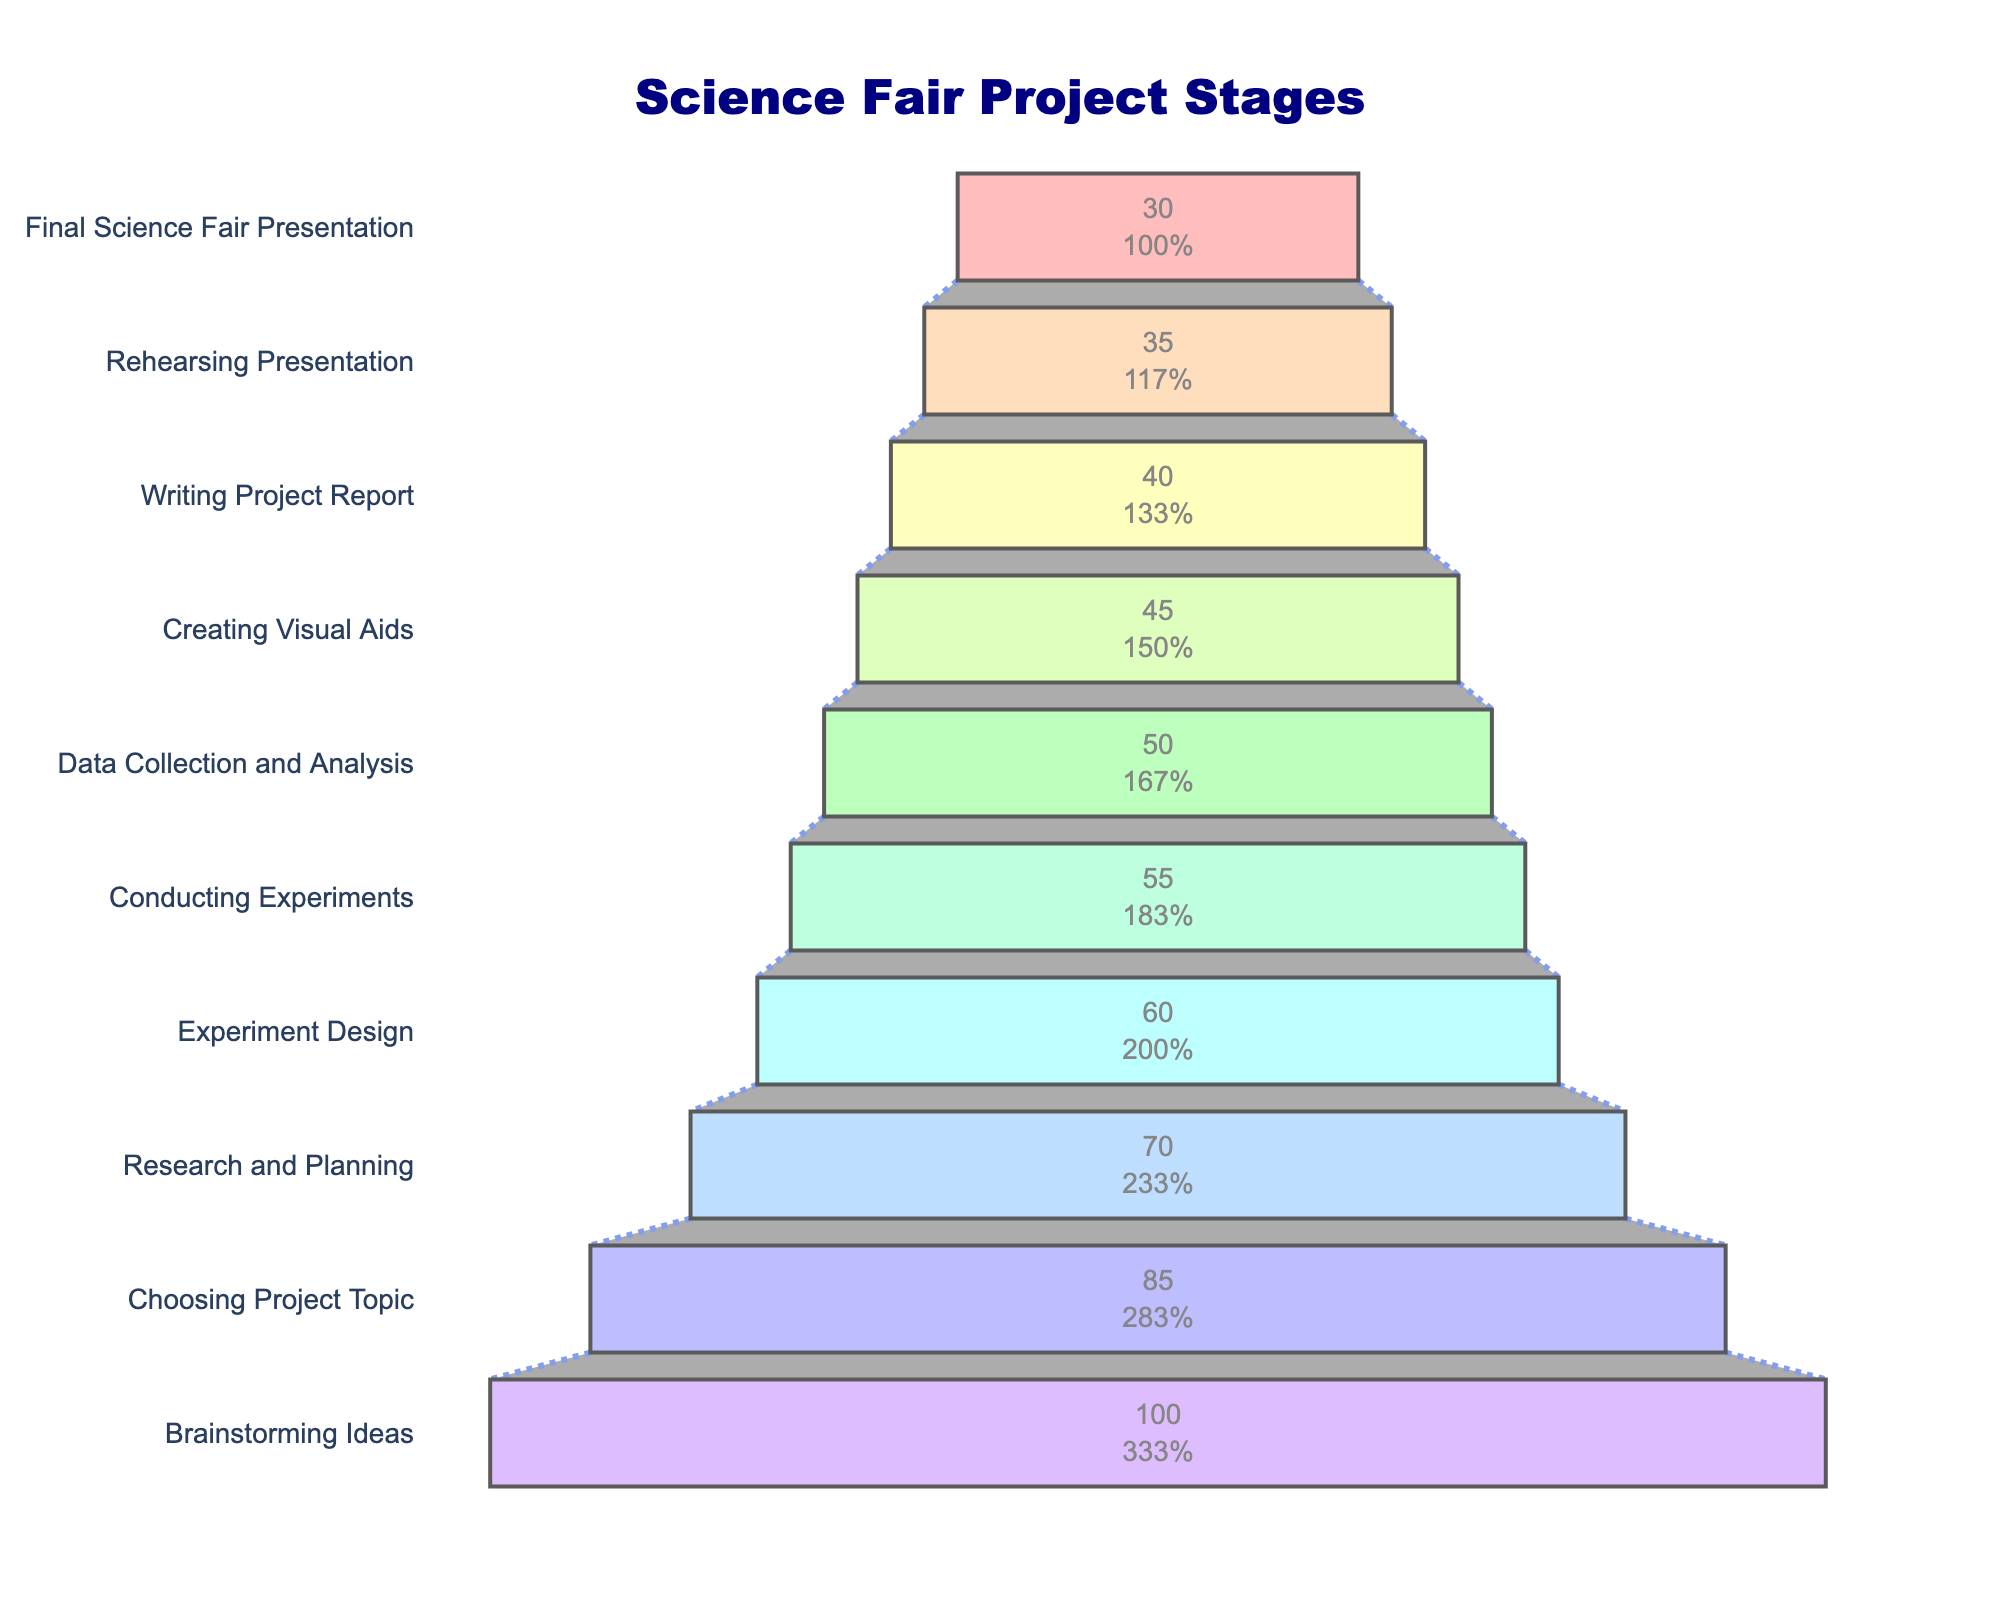How many stages are there in the science fair project funnel chart? By examining the chart, we can see the number of stages listed, from "Brainstorming Ideas" at the top to "Final Science Fair Presentation" at the bottom. Counting these stages gives us the total number.
Answer: 10 Which stage has the highest number of participants? By looking at the top value in the funnel chart, which corresponds to the stage with the most participants, we can easily determine the stage.
Answer: Brainstorming Ideas What percentage of participants remained from the Research and Planning stage to the Experiment Design stage? First, find the number of participants in both stages: Research and Planning has 70 participants, and Experiment Design has 60. The percentage remaining is calculated by (60 / 70) * 100.
Answer: ~85.7% How many stages have fewer than 50 participants? By scanning through the participant numbers for each stage, we identify and count those with fewer than 50 participants. Those stages are "Creating Visual Aids", "Writing Project Report", "Rehearsing Presentation", and "Final Science Fair Presentation".
Answer: 4 What is the decrease in participants from the Brainstorming Ideas stage to the Final Science Fair Presentation stage? Subtract the number of participants in the "Final Science Fair Presentation" stage (30) from those in the "Brainstorming Ideas" stage (100).
Answer: 70 How does the number of participants change from the Rehearsing Presentation stage to the Final Science Fair Presentation stage? Look at the number of participants in both stages: "Rehearsing Presentation" has 35 and "Final Science Fair Presentation" has 30. Subtracting these values gives the change.
Answer: 5 fewer Among the stages "Choosing Project Topic" and "Conducting Experiments", which has more participants? Compare the number of participants in both stages: "Choosing Project Topic" has 85 participants, and "Conducting Experiments" has 55.
Answer: Choosing Project Topic If the attrition rate at each stage were to double, how many participants would be left at the Final Science Fair Presentation stage? Calculate the number of participants lost at each stage and then assume doubling that loss. Continuously subtract the doubled losses from the initial 100 participants till calculating the final stage.
Answer: 0 (or close, as doubling attrition leads to rapid reduction) What is the average number of participants across all stages? Add up the number of participants in all stages and then divide by the number of stages. The sum is 570, and there are 10 stages, so the average is 570 / 10.
Answer: 57 Which stage sees the largest drop in participants compared to the previous stage? To find this, look at the difference in participant numbers between consecutive stages and identify the largest one. The biggest drop is between the "Brainstorming Ideas" (100) and "Choosing Project Topic" (85), which is a decrease of 15 participants.
Answer: Brainstorming Ideas to Choosing Project Topic 